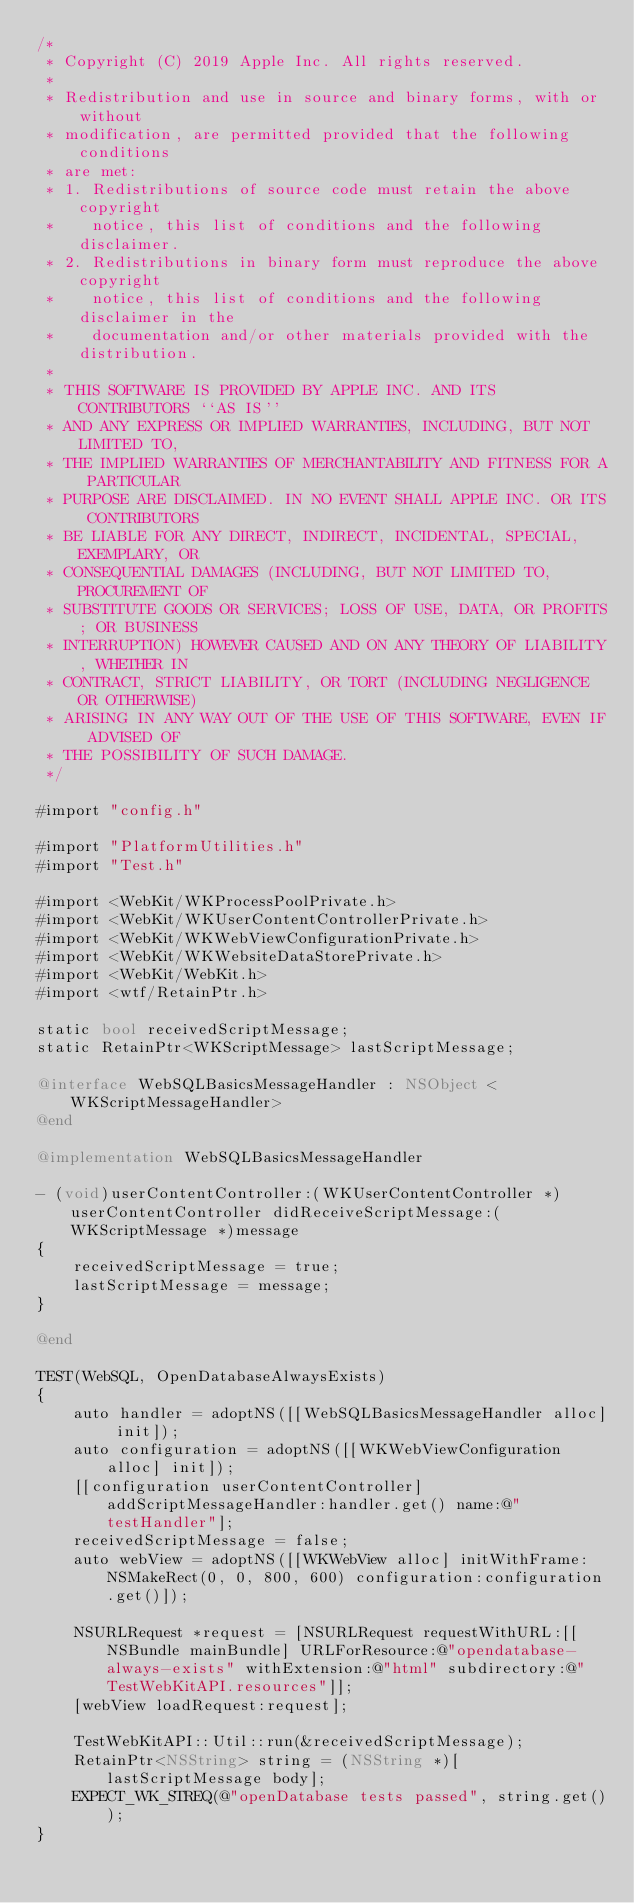Convert code to text. <code><loc_0><loc_0><loc_500><loc_500><_ObjectiveC_>/*
 * Copyright (C) 2019 Apple Inc. All rights reserved.
 *
 * Redistribution and use in source and binary forms, with or without
 * modification, are permitted provided that the following conditions
 * are met:
 * 1. Redistributions of source code must retain the above copyright
 *    notice, this list of conditions and the following disclaimer.
 * 2. Redistributions in binary form must reproduce the above copyright
 *    notice, this list of conditions and the following disclaimer in the
 *    documentation and/or other materials provided with the distribution.
 *
 * THIS SOFTWARE IS PROVIDED BY APPLE INC. AND ITS CONTRIBUTORS ``AS IS''
 * AND ANY EXPRESS OR IMPLIED WARRANTIES, INCLUDING, BUT NOT LIMITED TO,
 * THE IMPLIED WARRANTIES OF MERCHANTABILITY AND FITNESS FOR A PARTICULAR
 * PURPOSE ARE DISCLAIMED. IN NO EVENT SHALL APPLE INC. OR ITS CONTRIBUTORS
 * BE LIABLE FOR ANY DIRECT, INDIRECT, INCIDENTAL, SPECIAL, EXEMPLARY, OR
 * CONSEQUENTIAL DAMAGES (INCLUDING, BUT NOT LIMITED TO, PROCUREMENT OF
 * SUBSTITUTE GOODS OR SERVICES; LOSS OF USE, DATA, OR PROFITS; OR BUSINESS
 * INTERRUPTION) HOWEVER CAUSED AND ON ANY THEORY OF LIABILITY, WHETHER IN
 * CONTRACT, STRICT LIABILITY, OR TORT (INCLUDING NEGLIGENCE OR OTHERWISE)
 * ARISING IN ANY WAY OUT OF THE USE OF THIS SOFTWARE, EVEN IF ADVISED OF
 * THE POSSIBILITY OF SUCH DAMAGE.
 */

#import "config.h"

#import "PlatformUtilities.h"
#import "Test.h"

#import <WebKit/WKProcessPoolPrivate.h>
#import <WebKit/WKUserContentControllerPrivate.h>
#import <WebKit/WKWebViewConfigurationPrivate.h>
#import <WebKit/WKWebsiteDataStorePrivate.h>
#import <WebKit/WebKit.h>
#import <wtf/RetainPtr.h>

static bool receivedScriptMessage;
static RetainPtr<WKScriptMessage> lastScriptMessage;

@interface WebSQLBasicsMessageHandler : NSObject <WKScriptMessageHandler>
@end

@implementation WebSQLBasicsMessageHandler

- (void)userContentController:(WKUserContentController *)userContentController didReceiveScriptMessage:(WKScriptMessage *)message
{
    receivedScriptMessage = true;
    lastScriptMessage = message;
}

@end

TEST(WebSQL, OpenDatabaseAlwaysExists)
{
    auto handler = adoptNS([[WebSQLBasicsMessageHandler alloc] init]);
    auto configuration = adoptNS([[WKWebViewConfiguration alloc] init]);
    [[configuration userContentController] addScriptMessageHandler:handler.get() name:@"testHandler"];
    receivedScriptMessage = false;
    auto webView = adoptNS([[WKWebView alloc] initWithFrame:NSMakeRect(0, 0, 800, 600) configuration:configuration.get()]);

    NSURLRequest *request = [NSURLRequest requestWithURL:[[NSBundle mainBundle] URLForResource:@"opendatabase-always-exists" withExtension:@"html" subdirectory:@"TestWebKitAPI.resources"]];
    [webView loadRequest:request];

    TestWebKitAPI::Util::run(&receivedScriptMessage);
    RetainPtr<NSString> string = (NSString *)[lastScriptMessage body];
    EXPECT_WK_STREQ(@"openDatabase tests passed", string.get());
}
</code> 